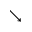Convert formula to latex. <formula><loc_0><loc_0><loc_500><loc_500>\searrow</formula> 